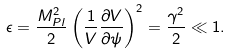Convert formula to latex. <formula><loc_0><loc_0><loc_500><loc_500>\epsilon = \frac { M _ { P l } ^ { 2 } } { 2 } \left ( \frac { 1 } { V } \frac { \partial V } { \partial \psi } \right ) ^ { 2 } = \frac { \gamma ^ { 2 } } { 2 } \ll 1 .</formula> 